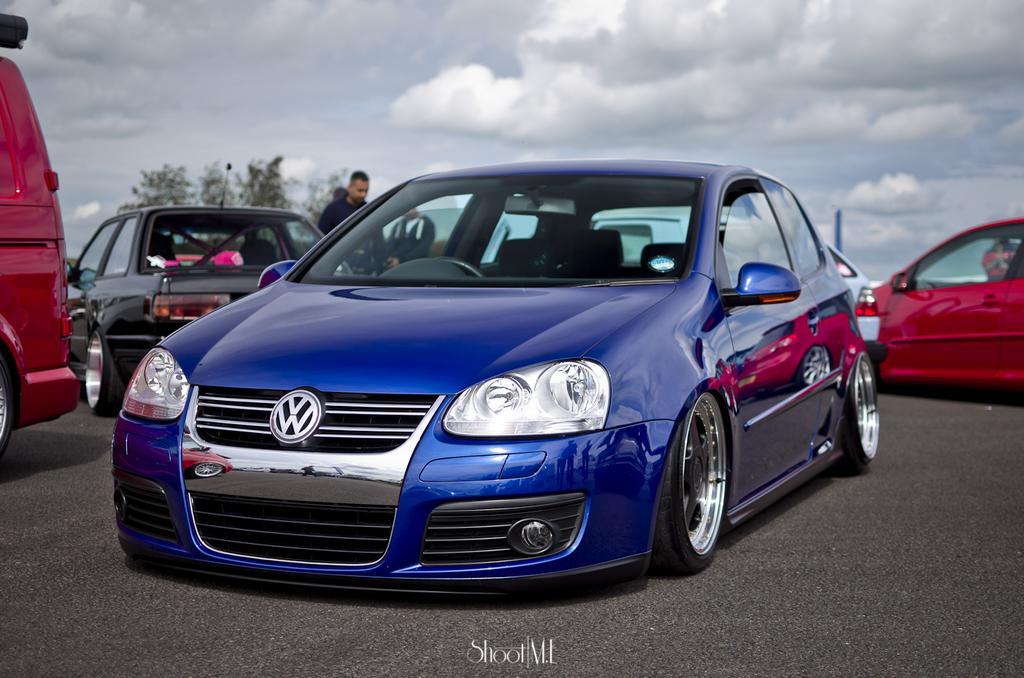Please provide a concise description of this image. In the image there are few cars on the road. Behind them there is a man, pole and a tree. At the top of the image there is sky with clouds. At the bottom of the image there is a name. 